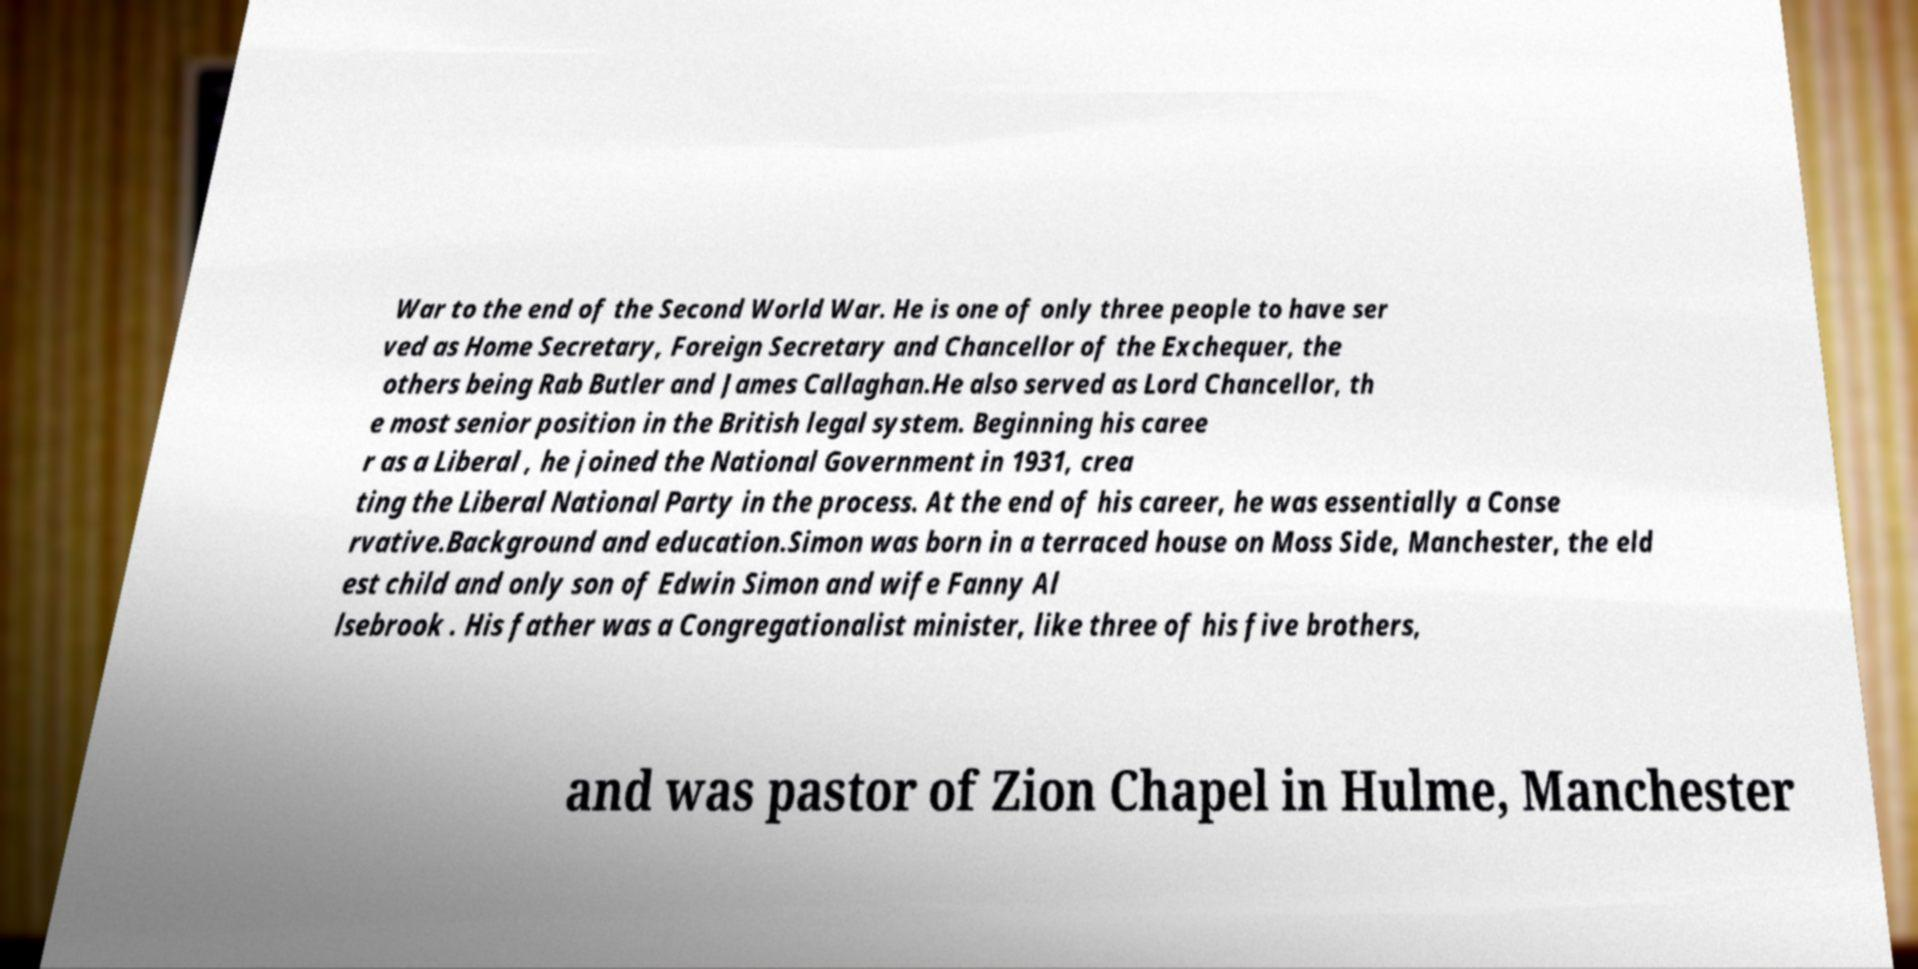Can you read and provide the text displayed in the image?This photo seems to have some interesting text. Can you extract and type it out for me? War to the end of the Second World War. He is one of only three people to have ser ved as Home Secretary, Foreign Secretary and Chancellor of the Exchequer, the others being Rab Butler and James Callaghan.He also served as Lord Chancellor, th e most senior position in the British legal system. Beginning his caree r as a Liberal , he joined the National Government in 1931, crea ting the Liberal National Party in the process. At the end of his career, he was essentially a Conse rvative.Background and education.Simon was born in a terraced house on Moss Side, Manchester, the eld est child and only son of Edwin Simon and wife Fanny Al lsebrook . His father was a Congregationalist minister, like three of his five brothers, and was pastor of Zion Chapel in Hulme, Manchester 